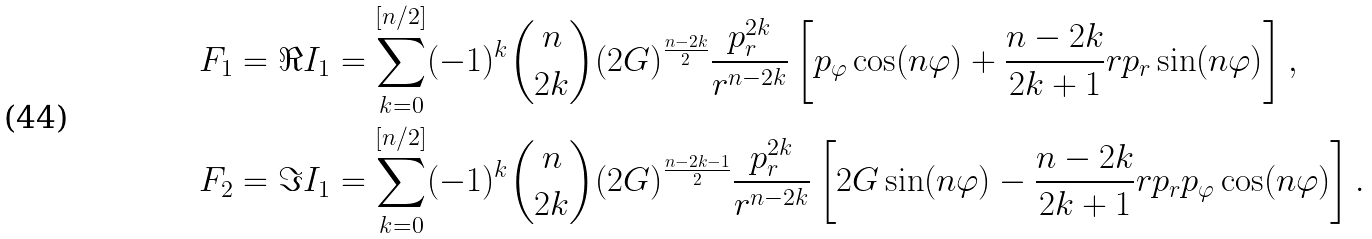Convert formula to latex. <formula><loc_0><loc_0><loc_500><loc_500>& F _ { 1 } = \Re I _ { 1 } = \sum _ { k = 0 } ^ { [ n / 2 ] } ( - 1 ) ^ { k } \binom { n } { 2 k } ( 2 G ) ^ { \frac { n - 2 k } { 2 } } \frac { p _ { r } ^ { 2 k } } { r ^ { n - 2 k } } \left [ p _ { \varphi } \cos ( n \varphi ) + \frac { n - 2 k } { 2 k + 1 } r p _ { r } \sin ( n \varphi ) \right ] , \\ & F _ { 2 } = \Im I _ { 1 } = \sum _ { k = 0 } ^ { [ n / 2 ] } ( - 1 ) ^ { k } \binom { n } { 2 k } ( 2 G ) ^ { \frac { n - 2 k - 1 } { 2 } } \frac { p _ { r } ^ { 2 k } } { r ^ { n - 2 k } } \left [ 2 G \sin ( n \varphi ) - \frac { n - 2 k } { 2 k + 1 } r p _ { r } p _ { \varphi } \cos ( n \varphi ) \right ] .</formula> 